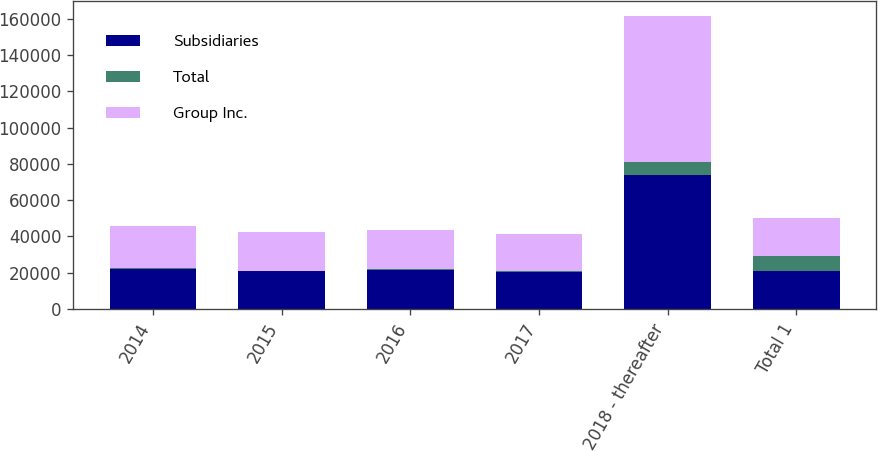<chart> <loc_0><loc_0><loc_500><loc_500><stacked_bar_chart><ecel><fcel>2014<fcel>2015<fcel>2016<fcel>2017<fcel>2018 - thereafter<fcel>Total 1<nl><fcel>Subsidiaries<fcel>22279<fcel>20734<fcel>21717<fcel>20218<fcel>73731<fcel>20723<nl><fcel>Total<fcel>496<fcel>411<fcel>172<fcel>494<fcel>7053<fcel>8626<nl><fcel>Group Inc.<fcel>22775<fcel>21145<fcel>21889<fcel>20712<fcel>80784<fcel>20723<nl></chart> 